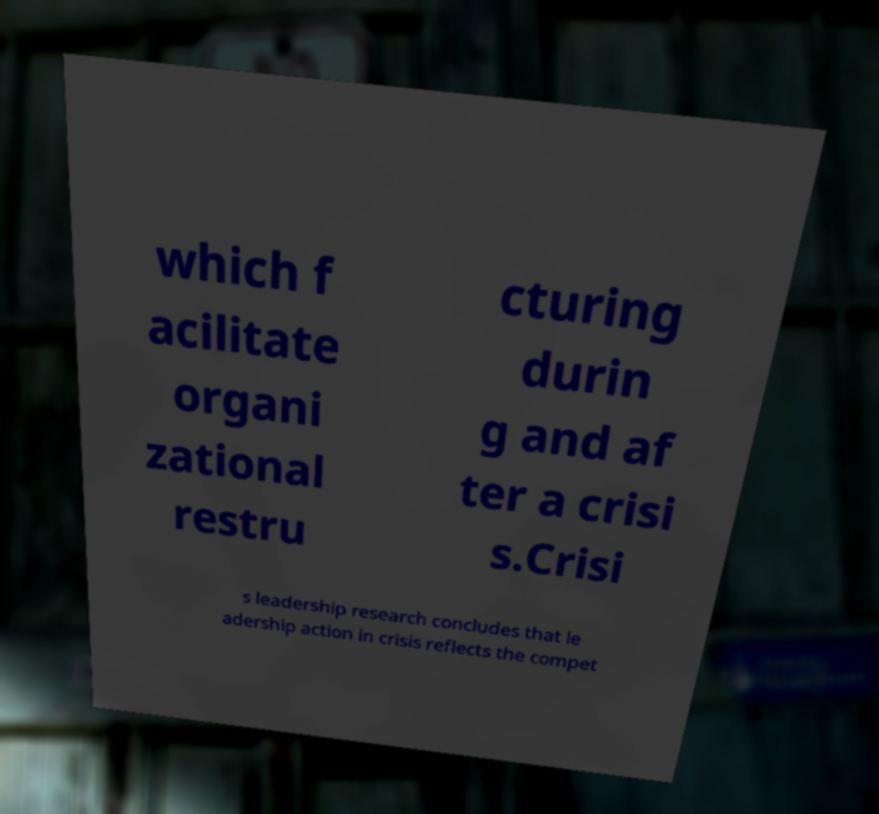Could you assist in decoding the text presented in this image and type it out clearly? which f acilitate organi zational restru cturing durin g and af ter a crisi s.Crisi s leadership research concludes that le adership action in crisis reflects the compet 